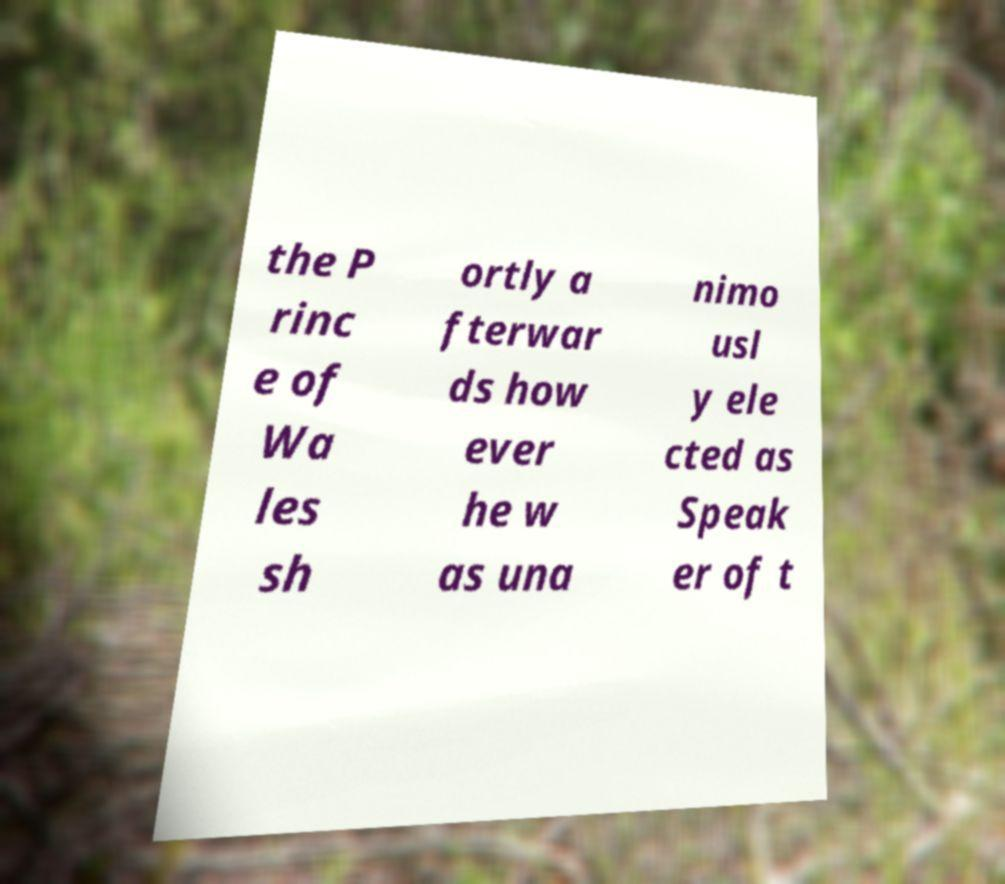I need the written content from this picture converted into text. Can you do that? the P rinc e of Wa les sh ortly a fterwar ds how ever he w as una nimo usl y ele cted as Speak er of t 